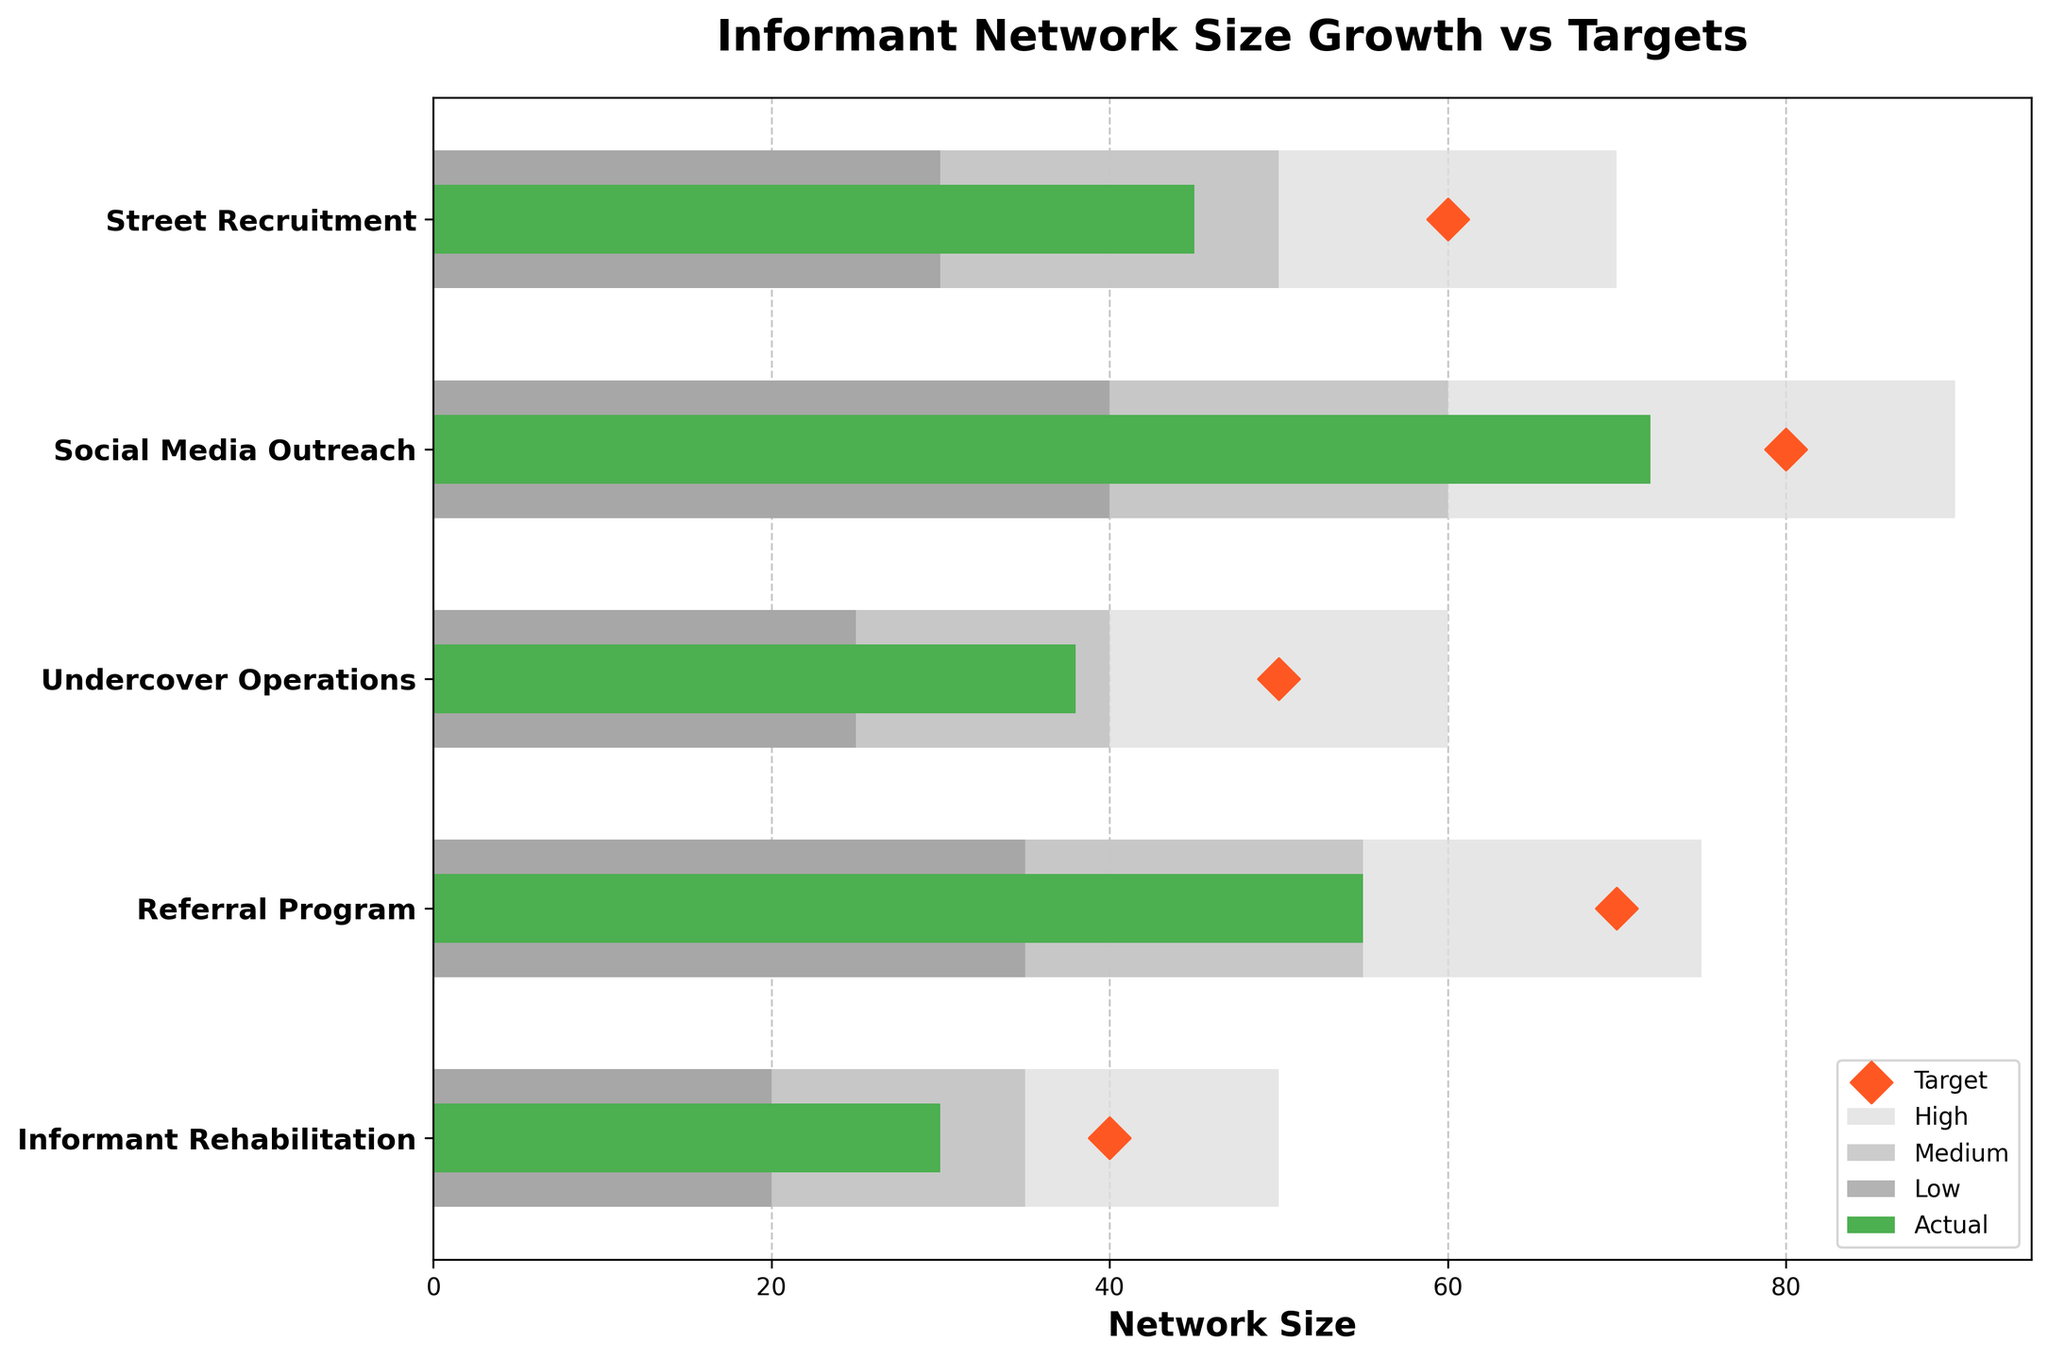What's the title of the figure? The title is displayed at the top of the figure in larger, bold font. It helps in understanding what the entire chart represents.
Answer: Informant Network Size Growth vs Targets Which recruitment method has the highest actual value? By observing the green bars, we note that the "Social Media Outreach" section has the longest green bar, indicating it has the highest actual value.
Answer: Social Media Outreach What's the actual value achieved by Street Recruitment? The length of the green bar corresponding to "Street Recruitment" indicates its actual network size growth value.
Answer: 45 Which recruitment method had the closest actual value to its target? By comparing the actual values (green bars) and target markers (orange diamonds), we see that "Referral Program" has values closest to each other.
Answer: Referral Program Which recruitment method exceeded its medium growth level? If the actual value (green bar) extends beyond the medium range (middle grey bar), it's considered exceeding. "Social Media Outreach" and “Referral Program” both have actual values extending into the high range, exceeding the medium level.
Answer: Social Media Outreach and Referral Program What is the difference between the target and actual values for Undercover Operations? The target for "Undercover Operations" is 50 and the actual value achieved is 38. Subtract the actual value from the target to get the difference: 50 - 38 = 12.
Answer: 12 How many recruitment methods reached or exceeded their low growth targets? The low growth target is indicated by the first segment of the grey bar, so any green bar extending into or beyond this segment counts. "Street Recruitment", "Social Media Outreach", "Undercover Operations", "Referral Program", and "Informant Rehabilitation" all achieved this.
Answer: 5 What range did the actual value for Informant Rehabilitation fall into? By examining the green bar of "Informant Rehabilitation," it falls within the low growth range (first grey bar segment).
Answer: Low Which recruitment method has the largest gap between its highest potential target and actual value? Comparing the lengths of the high range (third grey bar) and actual value (green bar), "Social Media Outreach" has the largest gap from its highest target value of 90 and actual value of 72. The difference is 90 - 72 = 18.
Answer: Social Media Outreach How does the actual value of Social Media Outreach compare to its target value? The target for "Social Media Outreach" is 80, and its actual value is 72. Since 72 is less than 80, the actual value is below the target.
Answer: Below 